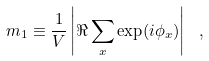<formula> <loc_0><loc_0><loc_500><loc_500>m _ { 1 } \equiv \frac { 1 } { V } \left | \Re \sum _ { x } \exp ( i \phi _ { x } ) \right | \ ,</formula> 